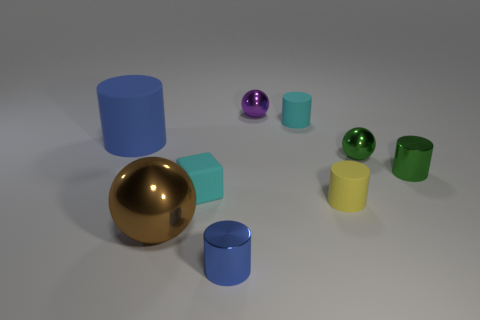Subtract all green cylinders. Subtract all yellow cubes. How many cylinders are left? 4 Add 1 cyan rubber spheres. How many objects exist? 10 Subtract all cylinders. How many objects are left? 4 Subtract 1 purple balls. How many objects are left? 8 Subtract all tiny purple shiny objects. Subtract all tiny balls. How many objects are left? 6 Add 9 yellow rubber cylinders. How many yellow rubber cylinders are left? 10 Add 7 small purple metal balls. How many small purple metal balls exist? 8 